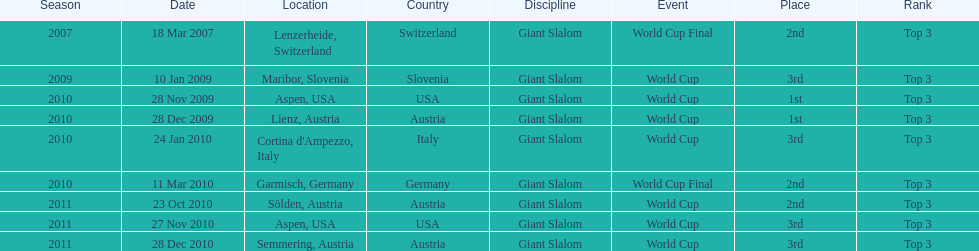How many races were in 2010? 5. 